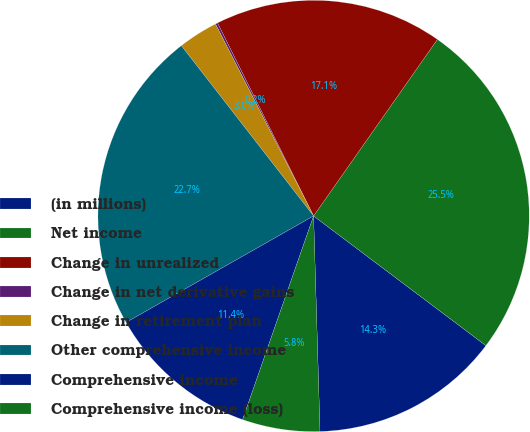Convert chart to OTSL. <chart><loc_0><loc_0><loc_500><loc_500><pie_chart><fcel>(in millions)<fcel>Net income<fcel>Change in unrealized<fcel>Change in net derivative gains<fcel>Change in retirement plan<fcel>Other comprehensive income<fcel>Comprehensive income<fcel>Comprehensive income (loss)<nl><fcel>14.26%<fcel>25.53%<fcel>17.08%<fcel>0.17%<fcel>2.99%<fcel>22.71%<fcel>11.44%<fcel>5.81%<nl></chart> 